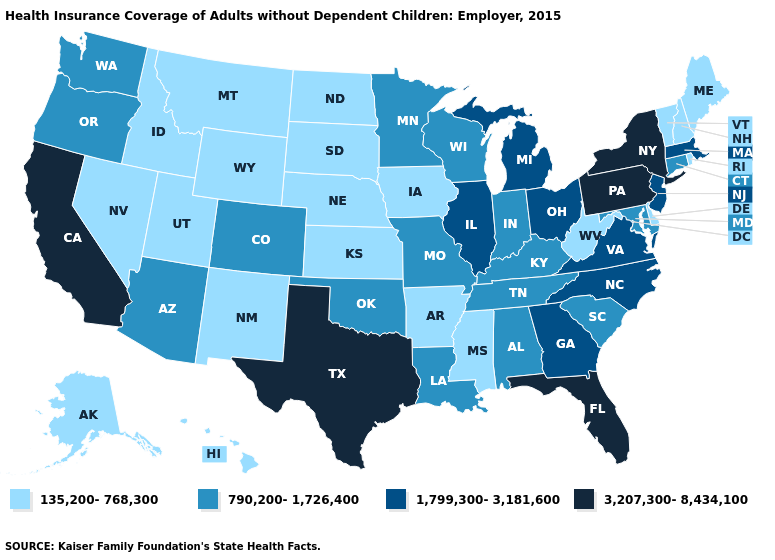Name the states that have a value in the range 790,200-1,726,400?
Concise answer only. Alabama, Arizona, Colorado, Connecticut, Indiana, Kentucky, Louisiana, Maryland, Minnesota, Missouri, Oklahoma, Oregon, South Carolina, Tennessee, Washington, Wisconsin. What is the value of Maine?
Concise answer only. 135,200-768,300. What is the highest value in the USA?
Give a very brief answer. 3,207,300-8,434,100. Which states have the highest value in the USA?
Write a very short answer. California, Florida, New York, Pennsylvania, Texas. Name the states that have a value in the range 135,200-768,300?
Be succinct. Alaska, Arkansas, Delaware, Hawaii, Idaho, Iowa, Kansas, Maine, Mississippi, Montana, Nebraska, Nevada, New Hampshire, New Mexico, North Dakota, Rhode Island, South Dakota, Utah, Vermont, West Virginia, Wyoming. What is the value of Louisiana?
Give a very brief answer. 790,200-1,726,400. Name the states that have a value in the range 135,200-768,300?
Keep it brief. Alaska, Arkansas, Delaware, Hawaii, Idaho, Iowa, Kansas, Maine, Mississippi, Montana, Nebraska, Nevada, New Hampshire, New Mexico, North Dakota, Rhode Island, South Dakota, Utah, Vermont, West Virginia, Wyoming. What is the highest value in the Northeast ?
Be succinct. 3,207,300-8,434,100. Does Iowa have a higher value than Pennsylvania?
Keep it brief. No. Does Maryland have a lower value than Mississippi?
Answer briefly. No. Name the states that have a value in the range 790,200-1,726,400?
Keep it brief. Alabama, Arizona, Colorado, Connecticut, Indiana, Kentucky, Louisiana, Maryland, Minnesota, Missouri, Oklahoma, Oregon, South Carolina, Tennessee, Washington, Wisconsin. Does Maine have the lowest value in the Northeast?
Be succinct. Yes. Name the states that have a value in the range 790,200-1,726,400?
Concise answer only. Alabama, Arizona, Colorado, Connecticut, Indiana, Kentucky, Louisiana, Maryland, Minnesota, Missouri, Oklahoma, Oregon, South Carolina, Tennessee, Washington, Wisconsin. What is the value of Maryland?
Concise answer only. 790,200-1,726,400. 